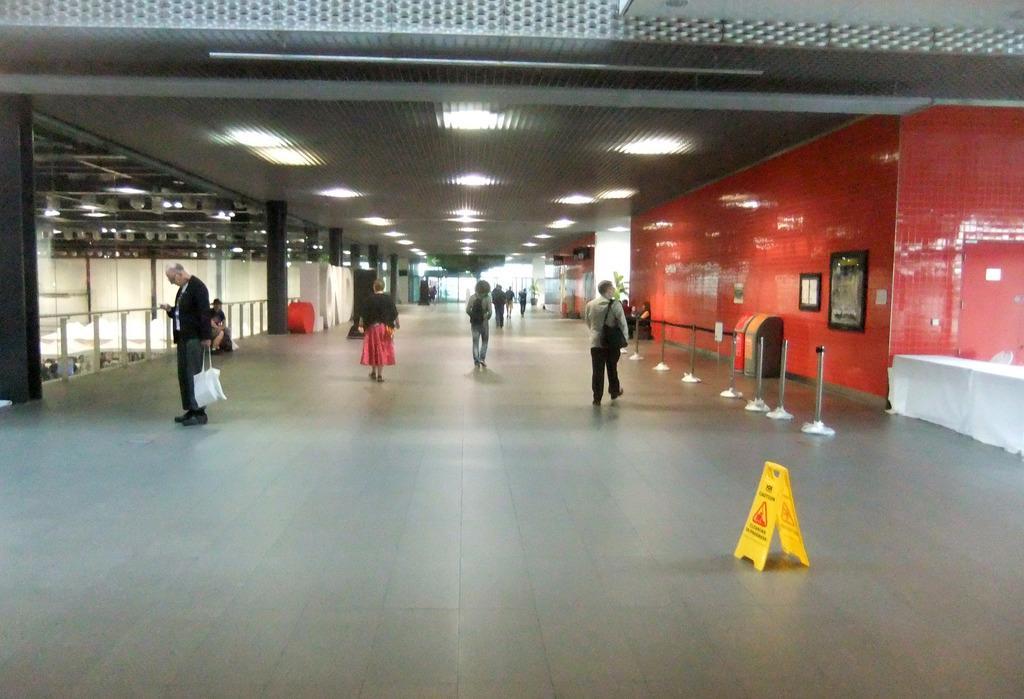Could you give a brief overview of what you see in this image? In this image we can see some people standing on the floor. One person is holding a bag in his hand. On the left side of the image we can see two people sitting, we can also see railing. On the right side of the image we can see some poles, machines placed on ground, table and photo frames on the wall. At the top of the image we can see some lights on the roof. 